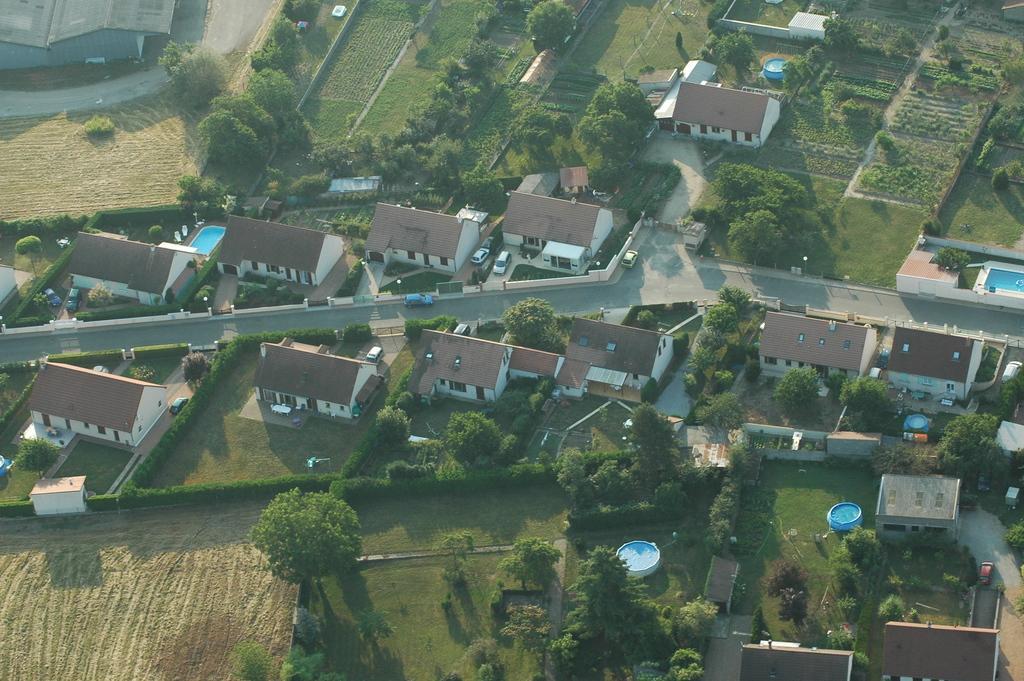Please provide a concise description of this image. In the picture we can see a Ariel view of the village with some houses and between the houses we can see a road with some cars on it and near the houses we can see some plants, trees and crops. 